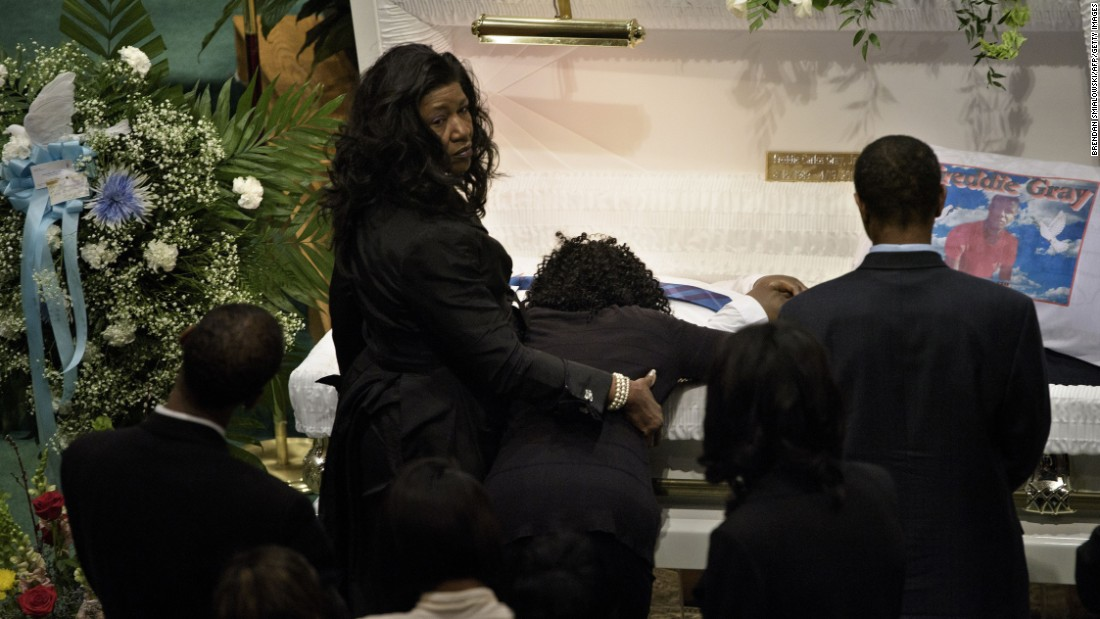Can you describe the atmosphere of the room given the visible elements and expressions observed? The atmosphere in the room is heavy with mourning and respect. The floral arrangements and the subdued lighting contribute to a serene yet somber ambiance. People's solemn faces and reserved body language, all focused towards the casket, underscore a shared solemnity permeating the space, emphasizing both the gravity and the communal nature of the occasion. 